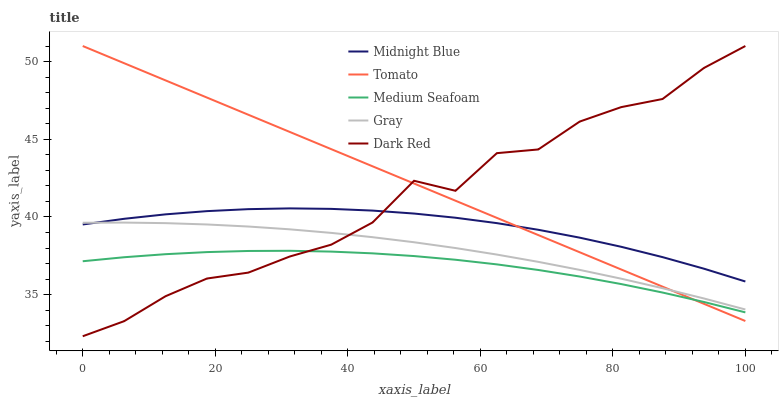Does Medium Seafoam have the minimum area under the curve?
Answer yes or no. Yes. Does Tomato have the maximum area under the curve?
Answer yes or no. Yes. Does Gray have the minimum area under the curve?
Answer yes or no. No. Does Gray have the maximum area under the curve?
Answer yes or no. No. Is Tomato the smoothest?
Answer yes or no. Yes. Is Dark Red the roughest?
Answer yes or no. Yes. Is Gray the smoothest?
Answer yes or no. No. Is Gray the roughest?
Answer yes or no. No. Does Dark Red have the lowest value?
Answer yes or no. Yes. Does Gray have the lowest value?
Answer yes or no. No. Does Dark Red have the highest value?
Answer yes or no. Yes. Does Gray have the highest value?
Answer yes or no. No. Is Medium Seafoam less than Gray?
Answer yes or no. Yes. Is Gray greater than Medium Seafoam?
Answer yes or no. Yes. Does Midnight Blue intersect Tomato?
Answer yes or no. Yes. Is Midnight Blue less than Tomato?
Answer yes or no. No. Is Midnight Blue greater than Tomato?
Answer yes or no. No. Does Medium Seafoam intersect Gray?
Answer yes or no. No. 